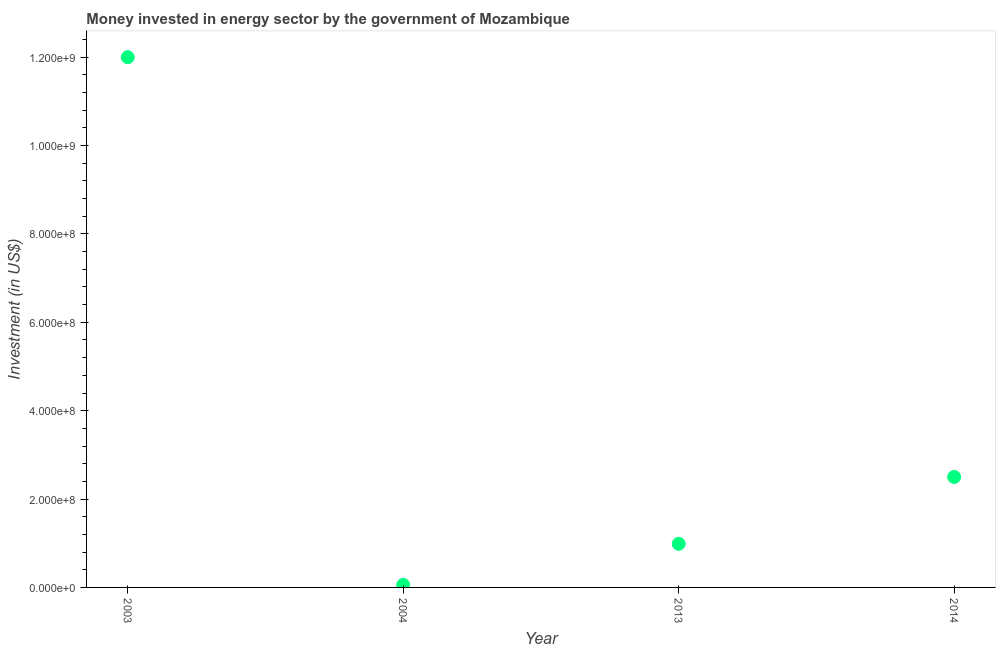What is the investment in energy in 2013?
Provide a short and direct response. 9.87e+07. Across all years, what is the maximum investment in energy?
Offer a very short reply. 1.20e+09. Across all years, what is the minimum investment in energy?
Ensure brevity in your answer.  5.80e+06. In which year was the investment in energy minimum?
Make the answer very short. 2004. What is the sum of the investment in energy?
Keep it short and to the point. 1.55e+09. What is the difference between the investment in energy in 2004 and 2013?
Your answer should be compact. -9.29e+07. What is the average investment in energy per year?
Offer a terse response. 3.89e+08. What is the median investment in energy?
Offer a terse response. 1.74e+08. In how many years, is the investment in energy greater than 440000000 US$?
Keep it short and to the point. 1. What is the ratio of the investment in energy in 2003 to that in 2013?
Give a very brief answer. 12.16. Is the investment in energy in 2003 less than that in 2013?
Provide a succinct answer. No. What is the difference between the highest and the second highest investment in energy?
Provide a short and direct response. 9.50e+08. What is the difference between the highest and the lowest investment in energy?
Provide a succinct answer. 1.19e+09. In how many years, is the investment in energy greater than the average investment in energy taken over all years?
Your response must be concise. 1. Does the investment in energy monotonically increase over the years?
Keep it short and to the point. No. How many years are there in the graph?
Your answer should be very brief. 4. Are the values on the major ticks of Y-axis written in scientific E-notation?
Provide a short and direct response. Yes. Does the graph contain any zero values?
Offer a very short reply. No. Does the graph contain grids?
Ensure brevity in your answer.  No. What is the title of the graph?
Ensure brevity in your answer.  Money invested in energy sector by the government of Mozambique. What is the label or title of the X-axis?
Make the answer very short. Year. What is the label or title of the Y-axis?
Offer a terse response. Investment (in US$). What is the Investment (in US$) in 2003?
Your answer should be very brief. 1.20e+09. What is the Investment (in US$) in 2004?
Offer a very short reply. 5.80e+06. What is the Investment (in US$) in 2013?
Your response must be concise. 9.87e+07. What is the Investment (in US$) in 2014?
Keep it short and to the point. 2.50e+08. What is the difference between the Investment (in US$) in 2003 and 2004?
Provide a short and direct response. 1.19e+09. What is the difference between the Investment (in US$) in 2003 and 2013?
Offer a terse response. 1.10e+09. What is the difference between the Investment (in US$) in 2003 and 2014?
Your answer should be compact. 9.50e+08. What is the difference between the Investment (in US$) in 2004 and 2013?
Give a very brief answer. -9.29e+07. What is the difference between the Investment (in US$) in 2004 and 2014?
Give a very brief answer. -2.44e+08. What is the difference between the Investment (in US$) in 2013 and 2014?
Make the answer very short. -1.51e+08. What is the ratio of the Investment (in US$) in 2003 to that in 2004?
Your answer should be compact. 206.9. What is the ratio of the Investment (in US$) in 2003 to that in 2013?
Offer a terse response. 12.16. What is the ratio of the Investment (in US$) in 2003 to that in 2014?
Provide a succinct answer. 4.8. What is the ratio of the Investment (in US$) in 2004 to that in 2013?
Make the answer very short. 0.06. What is the ratio of the Investment (in US$) in 2004 to that in 2014?
Give a very brief answer. 0.02. What is the ratio of the Investment (in US$) in 2013 to that in 2014?
Make the answer very short. 0.4. 